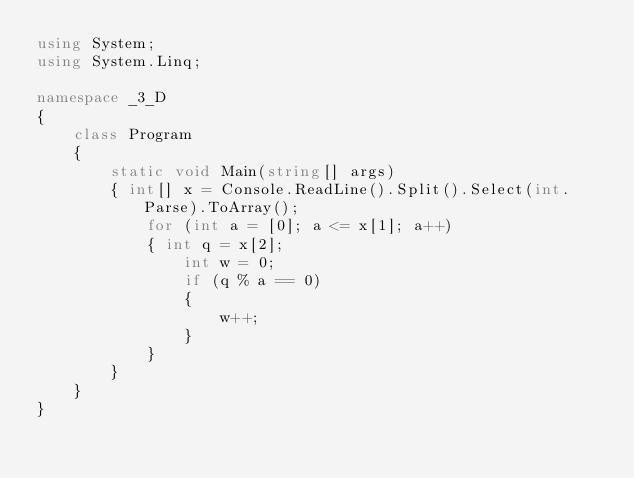Convert code to text. <code><loc_0><loc_0><loc_500><loc_500><_C#_>using System;
using System.Linq;

namespace _3_D
{
    class Program
    {
        static void Main(string[] args)
        { int[] x = Console.ReadLine().Split().Select(int.Parse).ToArray();
            for (int a = [0]; a <= x[1]; a++)
            { int q = x[2];
                int w = 0;
                if (q % a == 0)
                {
                    w++;
                }
            }
        }
    }
}</code> 